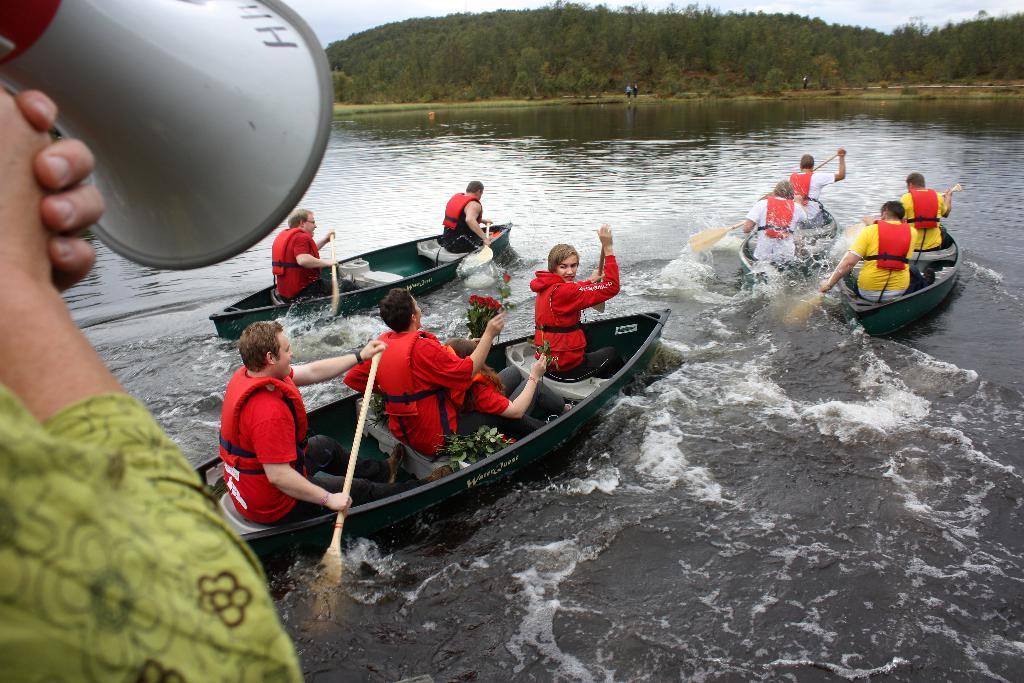Describe this image in one or two sentences. In this image there is water in the middle. In the water there are four boats. In the boats there are few people sitting by wearing the jackets and holding the sticks. On the left side there is a person who is holding the mic. In the background there are trees. 